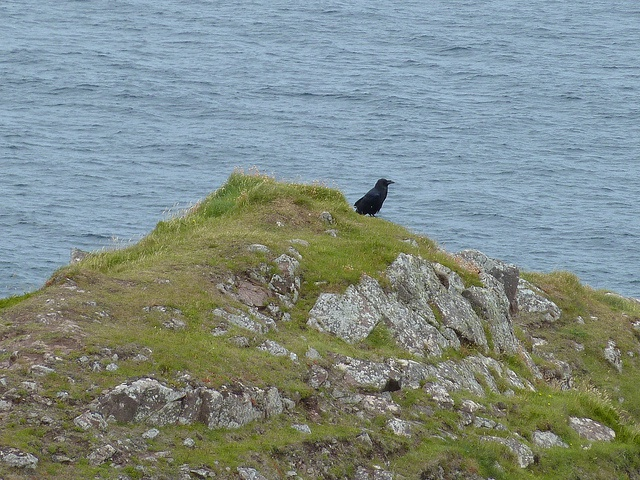Describe the objects in this image and their specific colors. I can see a bird in gray, black, and darkblue tones in this image. 